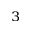<formula> <loc_0><loc_0><loc_500><loc_500>^ { 3 }</formula> 